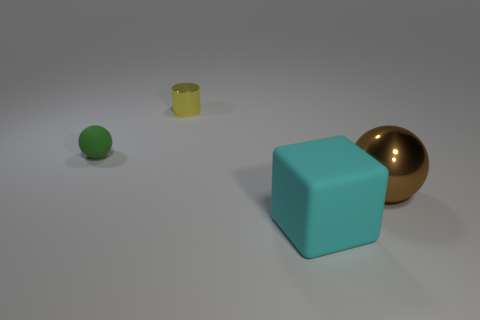The large rubber thing has what shape?
Provide a short and direct response. Cube. How many other things are made of the same material as the tiny cylinder?
Your response must be concise. 1. Is the yellow metallic object the same size as the green object?
Give a very brief answer. Yes. There is a brown thing that is right of the green rubber ball; what is its shape?
Provide a short and direct response. Sphere. There is a sphere that is to the right of the rubber object that is in front of the brown sphere; what color is it?
Provide a succinct answer. Brown. There is a matte thing behind the cube; is its shape the same as the rubber object that is on the right side of the small yellow metal cylinder?
Offer a terse response. No. There is a metal object that is the same size as the cyan block; what shape is it?
Give a very brief answer. Sphere. The sphere that is the same material as the cyan cube is what color?
Give a very brief answer. Green. There is a big brown metal object; is its shape the same as the matte object that is behind the matte block?
Provide a succinct answer. Yes. There is a thing that is the same size as the metallic cylinder; what material is it?
Your response must be concise. Rubber. 